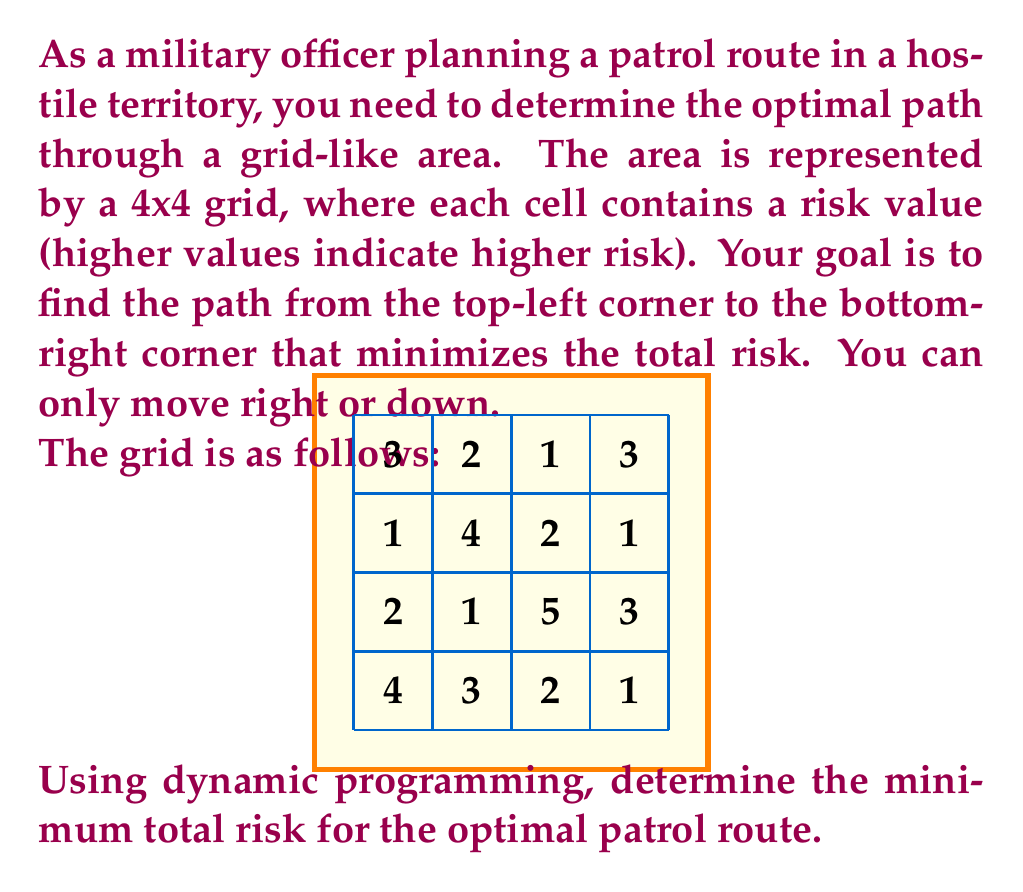Help me with this question. To solve this problem using dynamic programming, we'll create a table where each cell represents the minimum total risk to reach that cell from the start. We'll fill this table from top-left to bottom-right.

Let's denote our dynamic programming table as $DP[i][j]$, where $i$ and $j$ are row and column indices respectively.

Step 1: Initialize the first row and column of the DP table.
$DP[0][0] = 3$ (starting cell)
$DP[0][1] = DP[0][0] + 2 = 5$
$DP[0][2] = DP[0][1] + 1 = 6$
$DP[0][3] = DP[0][2] + 3 = 9$
$DP[1][0] = DP[0][0] + 1 = 4$
$DP[2][0] = DP[1][0] + 2 = 6$
$DP[3][0] = DP[2][0] + 4 = 10$

Step 2: Fill the rest of the DP table using the recurrence relation:
$DP[i][j] = \min(DP[i-1][j], DP[i][j-1]) + \text{risk}[i][j]$

$DP[1][1] = \min(5, 4) + 4 = 8$
$DP[1][2] = \min(6, 8) + 2 = 8$
$DP[1][3] = \min(9, 8) + 1 = 9$
$DP[2][1] = \min(8, 6) + 1 = 7$
$DP[2][2] = \min(8, 7) + 5 = 12$
$DP[2][3] = \min(9, 12) + 3 = 12$
$DP[3][1] = \min(7, 10) + 3 = 10$
$DP[3][2] = \min(12, 10) + 2 = 12$
$DP[3][3] = \min(12, 12) + 1 = 13$

The final DP table looks like this:

$$
\begin{bmatrix}
3 & 5 & 6 & 9 \\
4 & 8 & 8 & 9 \\
6 & 7 & 12 & 12 \\
10 & 10 & 12 & 13
\end{bmatrix}
$$

The value in the bottom-right cell, $DP[3][3] = 13$, represents the minimum total risk for the optimal patrol route.
Answer: 13 